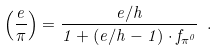<formula> <loc_0><loc_0><loc_500><loc_500>\left ( \frac { e } { \pi } \right ) = \frac { e / h } { 1 + ( e / h - 1 ) \cdot f _ { \pi ^ { 0 } } } \ .</formula> 